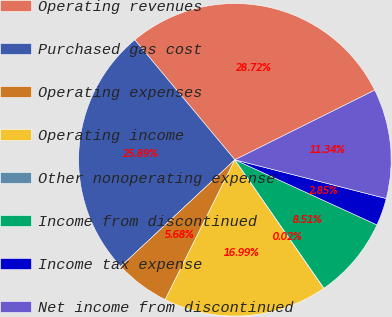<chart> <loc_0><loc_0><loc_500><loc_500><pie_chart><fcel>Operating revenues<fcel>Purchased gas cost<fcel>Operating expenses<fcel>Operating income<fcel>Other nonoperating expense<fcel>Income from discontinued<fcel>Income tax expense<fcel>Net income from discontinued<nl><fcel>28.72%<fcel>25.89%<fcel>5.68%<fcel>16.99%<fcel>0.02%<fcel>8.51%<fcel>2.85%<fcel>11.34%<nl></chart> 